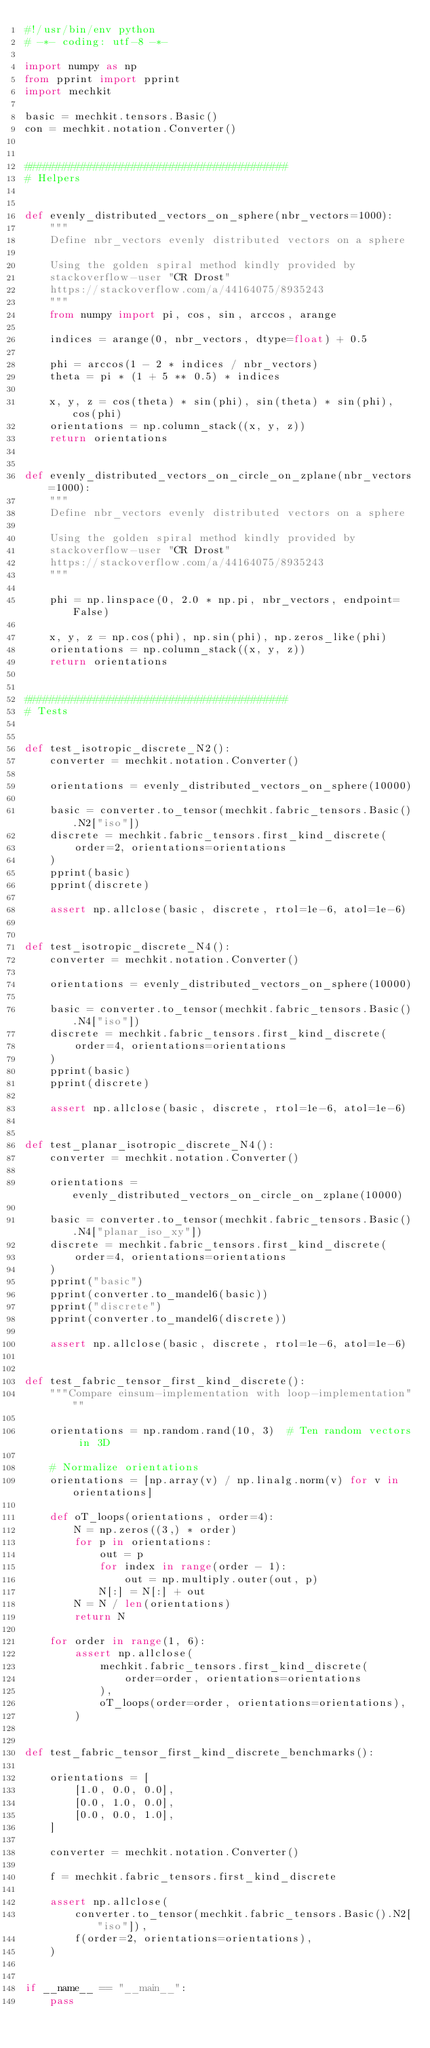<code> <loc_0><loc_0><loc_500><loc_500><_Python_>#!/usr/bin/env python
# -*- coding: utf-8 -*-

import numpy as np
from pprint import pprint
import mechkit

basic = mechkit.tensors.Basic()
con = mechkit.notation.Converter()


##########################################
# Helpers


def evenly_distributed_vectors_on_sphere(nbr_vectors=1000):
    """
    Define nbr_vectors evenly distributed vectors on a sphere

    Using the golden spiral method kindly provided by
    stackoverflow-user "CR Drost"
    https://stackoverflow.com/a/44164075/8935243
    """
    from numpy import pi, cos, sin, arccos, arange

    indices = arange(0, nbr_vectors, dtype=float) + 0.5

    phi = arccos(1 - 2 * indices / nbr_vectors)
    theta = pi * (1 + 5 ** 0.5) * indices

    x, y, z = cos(theta) * sin(phi), sin(theta) * sin(phi), cos(phi)
    orientations = np.column_stack((x, y, z))
    return orientations


def evenly_distributed_vectors_on_circle_on_zplane(nbr_vectors=1000):
    """
    Define nbr_vectors evenly distributed vectors on a sphere

    Using the golden spiral method kindly provided by
    stackoverflow-user "CR Drost"
    https://stackoverflow.com/a/44164075/8935243
    """

    phi = np.linspace(0, 2.0 * np.pi, nbr_vectors, endpoint=False)

    x, y, z = np.cos(phi), np.sin(phi), np.zeros_like(phi)
    orientations = np.column_stack((x, y, z))
    return orientations


##########################################
# Tests


def test_isotropic_discrete_N2():
    converter = mechkit.notation.Converter()

    orientations = evenly_distributed_vectors_on_sphere(10000)

    basic = converter.to_tensor(mechkit.fabric_tensors.Basic().N2["iso"])
    discrete = mechkit.fabric_tensors.first_kind_discrete(
        order=2, orientations=orientations
    )
    pprint(basic)
    pprint(discrete)

    assert np.allclose(basic, discrete, rtol=1e-6, atol=1e-6)


def test_isotropic_discrete_N4():
    converter = mechkit.notation.Converter()

    orientations = evenly_distributed_vectors_on_sphere(10000)

    basic = converter.to_tensor(mechkit.fabric_tensors.Basic().N4["iso"])
    discrete = mechkit.fabric_tensors.first_kind_discrete(
        order=4, orientations=orientations
    )
    pprint(basic)
    pprint(discrete)

    assert np.allclose(basic, discrete, rtol=1e-6, atol=1e-6)


def test_planar_isotropic_discrete_N4():
    converter = mechkit.notation.Converter()

    orientations = evenly_distributed_vectors_on_circle_on_zplane(10000)

    basic = converter.to_tensor(mechkit.fabric_tensors.Basic().N4["planar_iso_xy"])
    discrete = mechkit.fabric_tensors.first_kind_discrete(
        order=4, orientations=orientations
    )
    pprint("basic")
    pprint(converter.to_mandel6(basic))
    pprint("discrete")
    pprint(converter.to_mandel6(discrete))

    assert np.allclose(basic, discrete, rtol=1e-6, atol=1e-6)


def test_fabric_tensor_first_kind_discrete():
    """Compare einsum-implementation with loop-implementation"""

    orientations = np.random.rand(10, 3)  # Ten random vectors in 3D

    # Normalize orientations
    orientations = [np.array(v) / np.linalg.norm(v) for v in orientations]

    def oT_loops(orientations, order=4):
        N = np.zeros((3,) * order)
        for p in orientations:
            out = p
            for index in range(order - 1):
                out = np.multiply.outer(out, p)
            N[:] = N[:] + out
        N = N / len(orientations)
        return N

    for order in range(1, 6):
        assert np.allclose(
            mechkit.fabric_tensors.first_kind_discrete(
                order=order, orientations=orientations
            ),
            oT_loops(order=order, orientations=orientations),
        )


def test_fabric_tensor_first_kind_discrete_benchmarks():

    orientations = [
        [1.0, 0.0, 0.0],
        [0.0, 1.0, 0.0],
        [0.0, 0.0, 1.0],
    ]

    converter = mechkit.notation.Converter()

    f = mechkit.fabric_tensors.first_kind_discrete

    assert np.allclose(
        converter.to_tensor(mechkit.fabric_tensors.Basic().N2["iso"]),
        f(order=2, orientations=orientations),
    )


if __name__ == "__main__":
    pass
</code> 